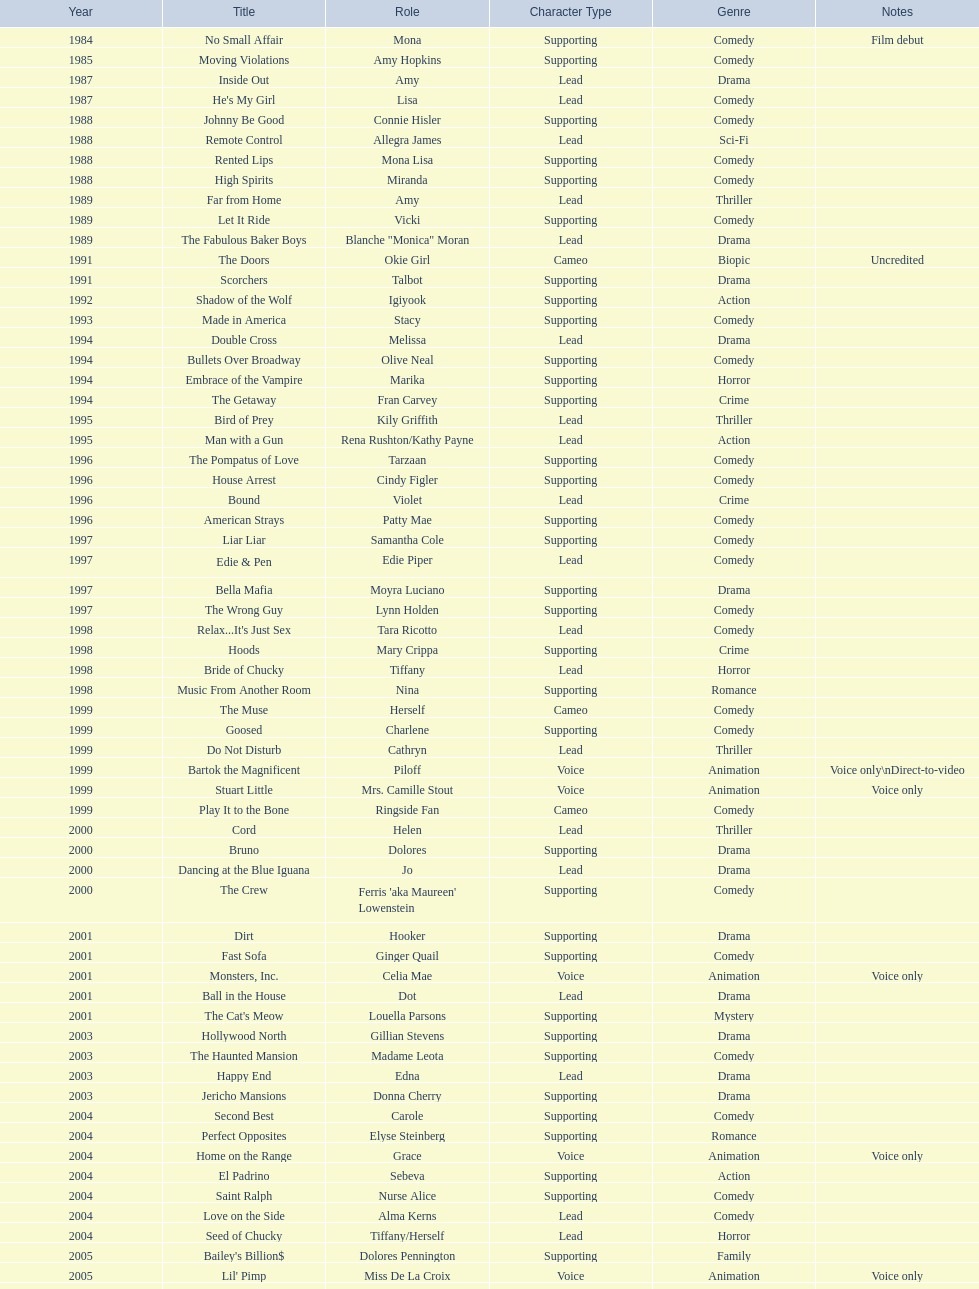How many rolls did jennifer tilly play in the 1980s? 11. 